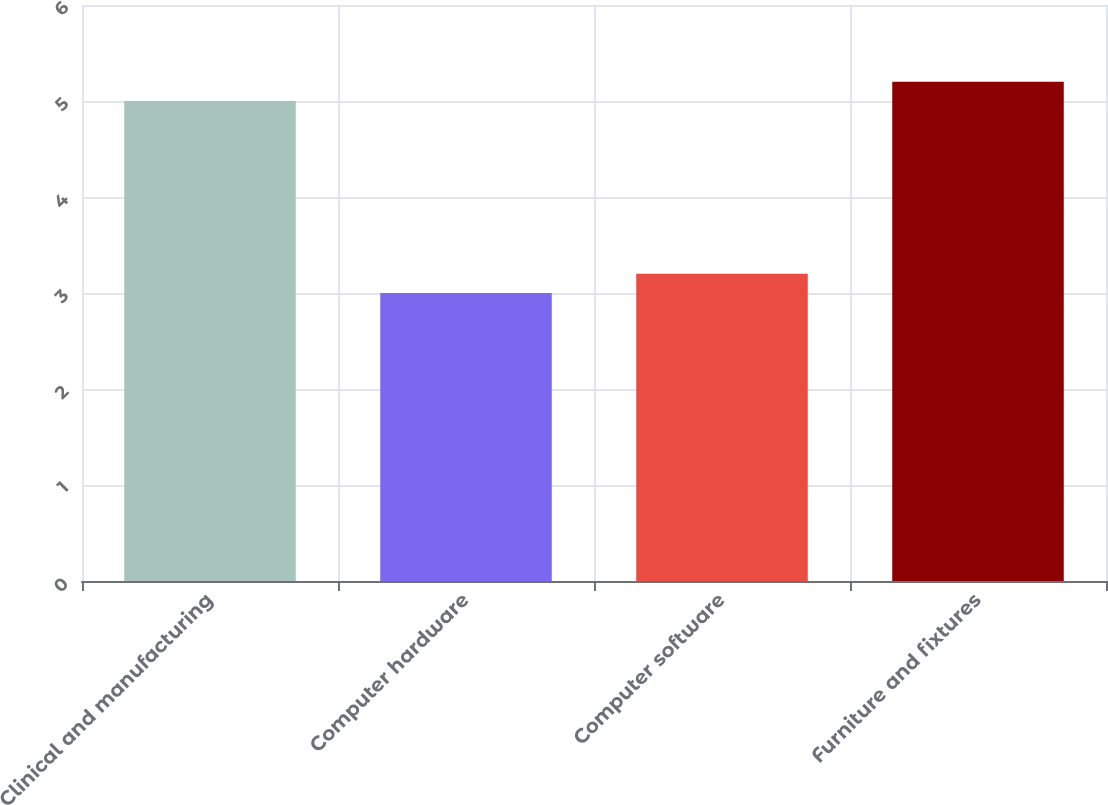<chart> <loc_0><loc_0><loc_500><loc_500><bar_chart><fcel>Clinical and manufacturing<fcel>Computer hardware<fcel>Computer software<fcel>Furniture and fixtures<nl><fcel>5<fcel>3<fcel>3.2<fcel>5.2<nl></chart> 